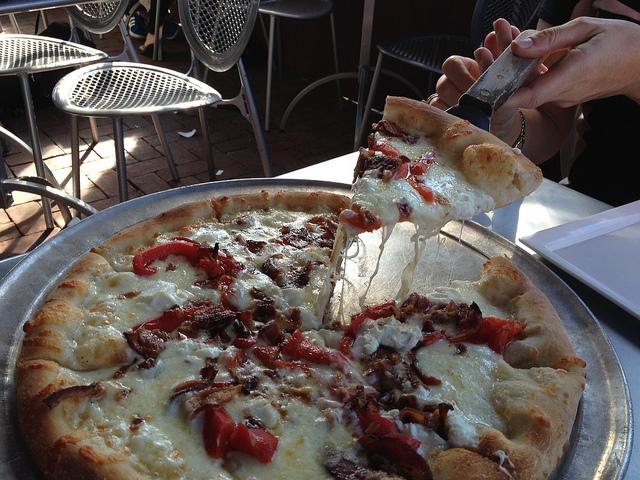How many chairs can be seen?
Quick response, please. 4. Is this pizza?
Give a very brief answer. Yes. Why would someone eat this?
Concise answer only. Hungry. 